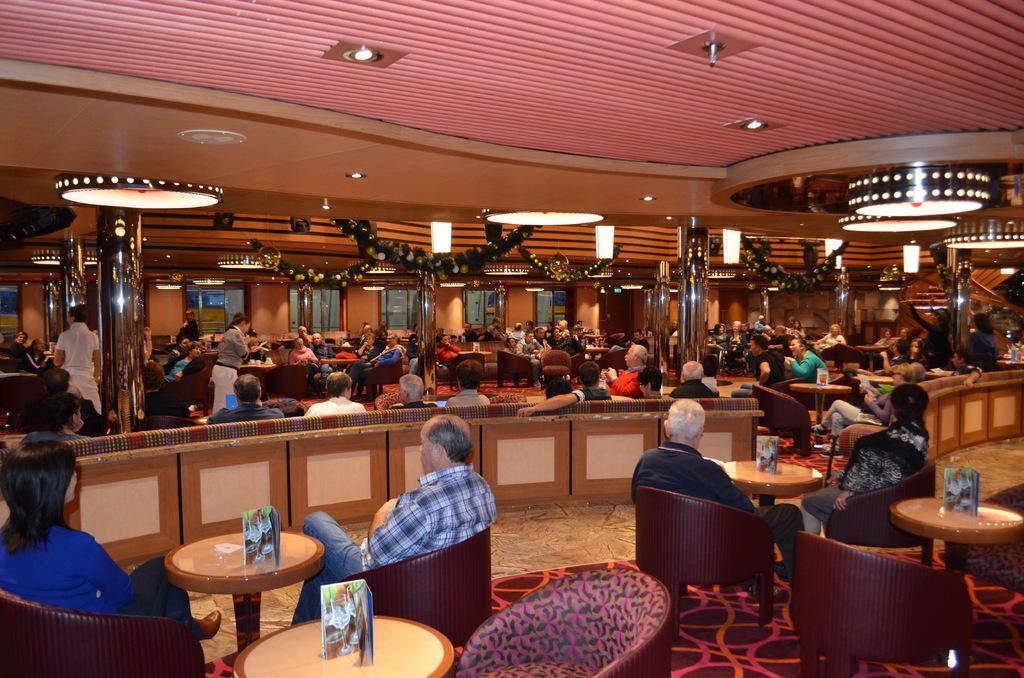Can you describe this image briefly? This picture describes about group of people few are seated on the chair and few are standing, in front of them we can find papers on the table, on top of them we can find couple of lights. 